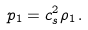Convert formula to latex. <formula><loc_0><loc_0><loc_500><loc_500>p _ { 1 } = c _ { s } ^ { 2 } \rho _ { 1 } \, .</formula> 